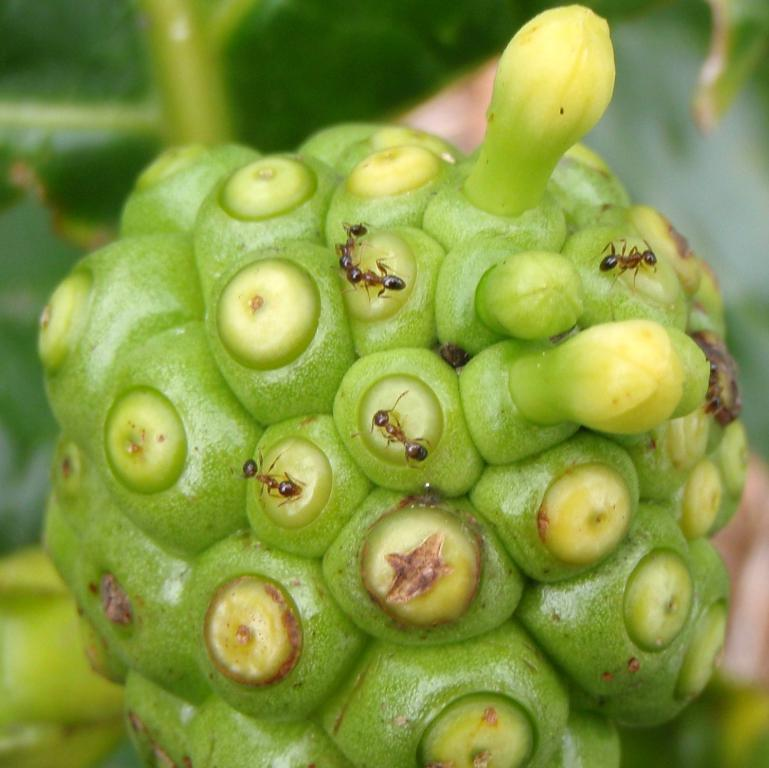How many buds are present on the plant in the image? There are two buds on the plant. What other features can be seen on the plant? There are leaves on the plant. Can you describe the topmost leaf in the image? A green color leaf is visible at the top of the image. What is the hourly income of the owl in the image? There is no owl present in the image, so it is not possible to determine its hourly income. 